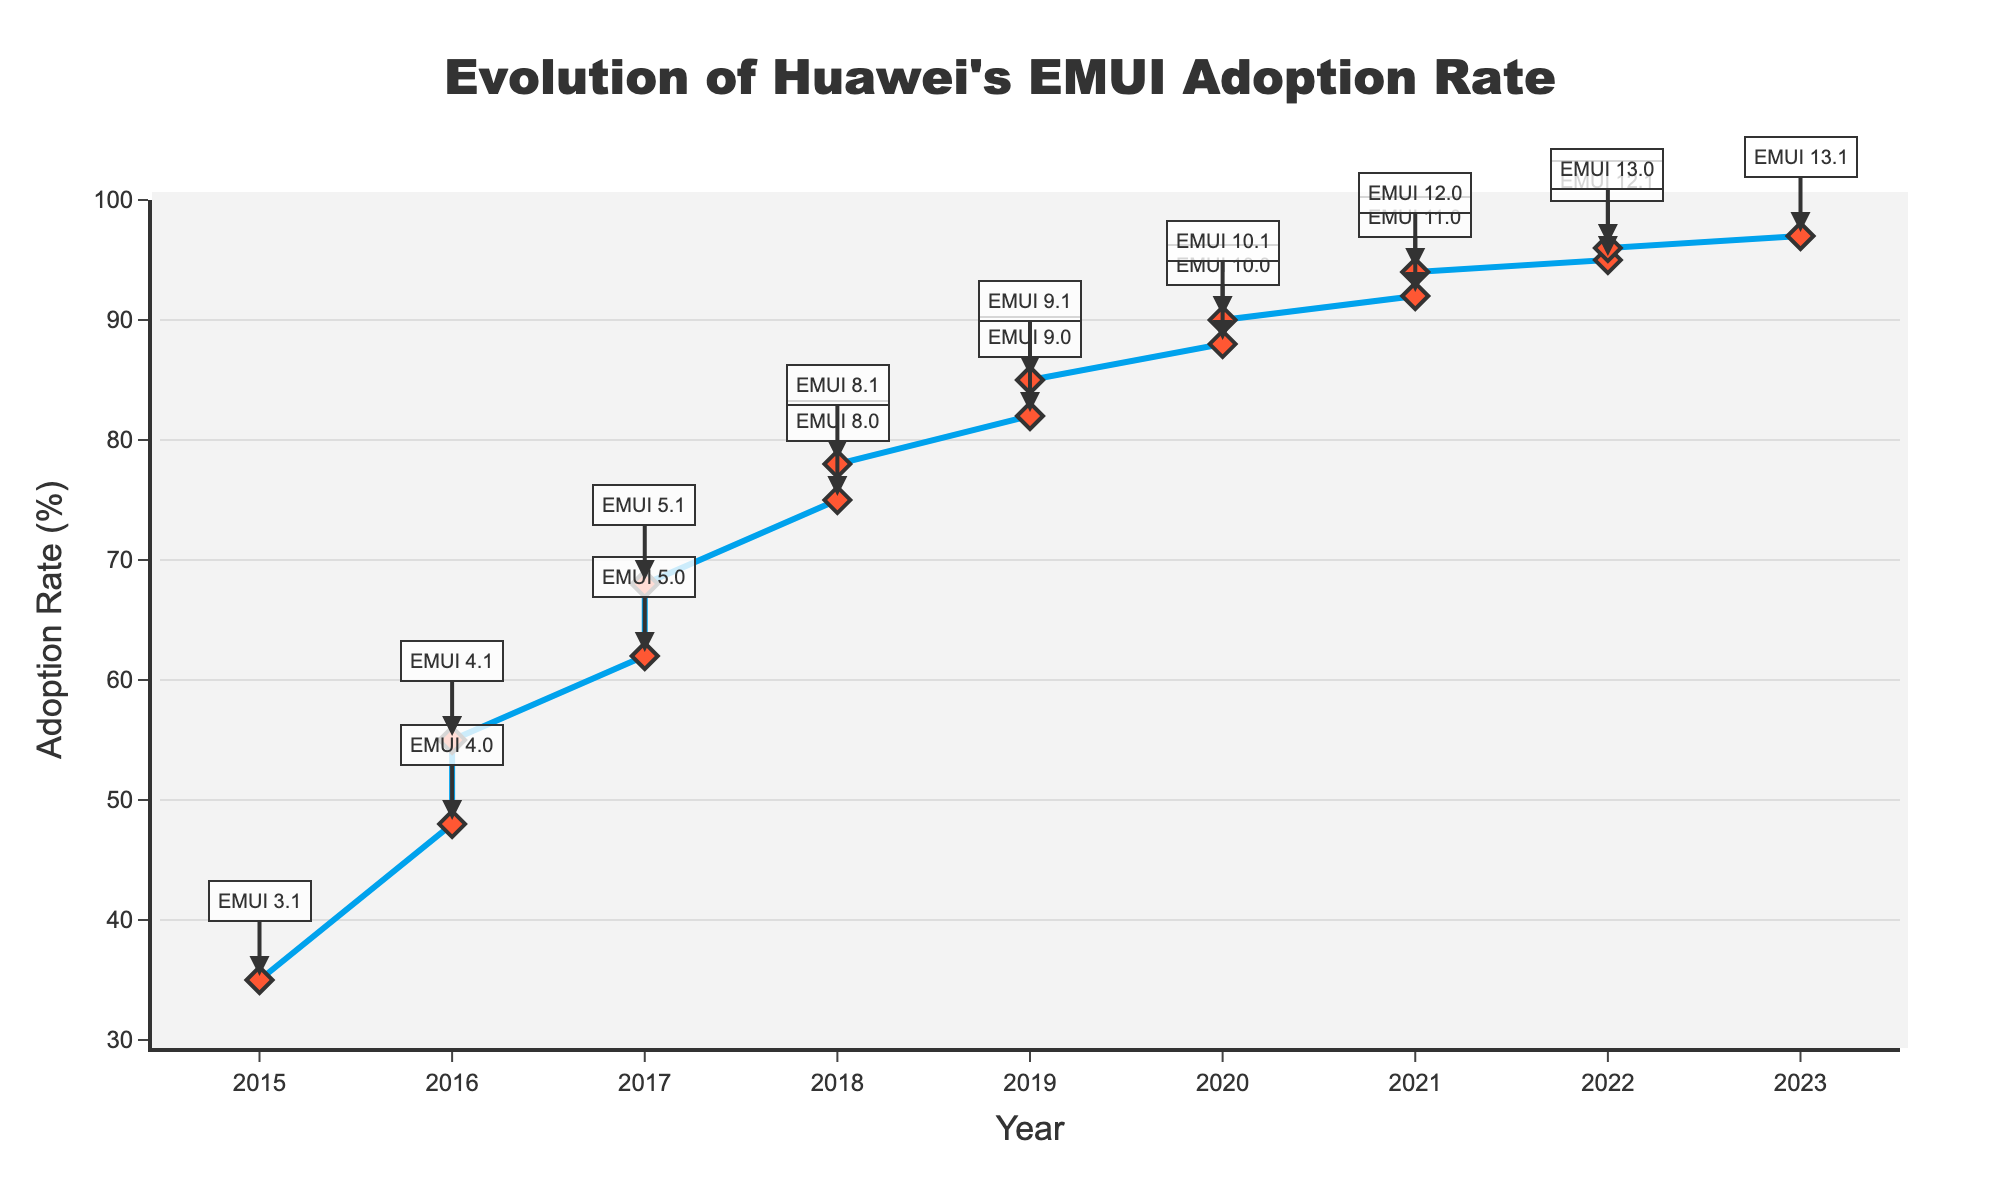What is the adoption rate of EMUI 5.0 in 2017? To find the adoption rate of EMUI 5.0 in 2017, locate the year 2017 on the x-axis and find the corresponding adoption rate for EMUI 5.0 on the y-axis.
Answer: 62% How much did the adoption rate increase from EMUI 10.0 to EMUI 13.0? Find the adoption rates of both EMUI 10.0 and EMUI 13.0 from the figure. Subtract the adoption rate of EMUI 10.0 from that of EMUI 13.0 (96-88).
Answer: 8% Which EMUI version had the highest adoption rate, and what was its rate? Look for the peak point on the line chart and identify the corresponding EMUI version and its adoption rate at this peak.
Answer: EMUI 13.1, 97% Between which consecutive EMUI versions was the largest adoption rate increase observed? Calculate the difference in adoption rates for each pair of consecutive EMUI versions and identify the pair with the largest difference. The largest increase is from EMUI 8.1 to EMUI 9.0 (82-78 = 4).
Answer: Between EMUI 8.1 and EMUI 9.0 How does the adoption rate of EMUI 9.1 compare to EMUI 10.1? Find the points for EMUI 9.1 and EMUI 10.1 and compare their adoption rates (85 vs 90).
Answer: EMUI 10.1 is higher What is the average adoption rate of all EMUI versions in 2020? Identify EMUI versions in the year 2020, which are EMUI 10.0 and EMUI 10.1, then calculate their average ((88+90)/2).
Answer: 89% What is the color of the markers used on the line chart? Observe the color of the markers on the line chart, which are visualized as diamond-shaped points.
Answer: Red Which year saw the highest increase in the adoption rate from the previous year? Calculate the annual increase in the adoption rate by subtracting the previous year's rate from the current year’s rate for each year and identify the maximum increase. The highest increase is 17% from 2015 (35) to 2016 (55).
Answer: 2016 